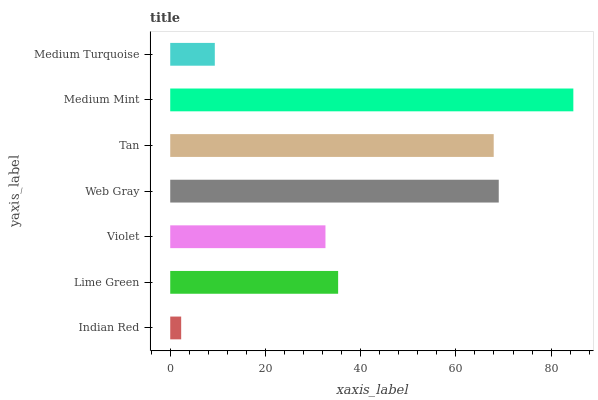Is Indian Red the minimum?
Answer yes or no. Yes. Is Medium Mint the maximum?
Answer yes or no. Yes. Is Lime Green the minimum?
Answer yes or no. No. Is Lime Green the maximum?
Answer yes or no. No. Is Lime Green greater than Indian Red?
Answer yes or no. Yes. Is Indian Red less than Lime Green?
Answer yes or no. Yes. Is Indian Red greater than Lime Green?
Answer yes or no. No. Is Lime Green less than Indian Red?
Answer yes or no. No. Is Lime Green the high median?
Answer yes or no. Yes. Is Lime Green the low median?
Answer yes or no. Yes. Is Web Gray the high median?
Answer yes or no. No. Is Web Gray the low median?
Answer yes or no. No. 